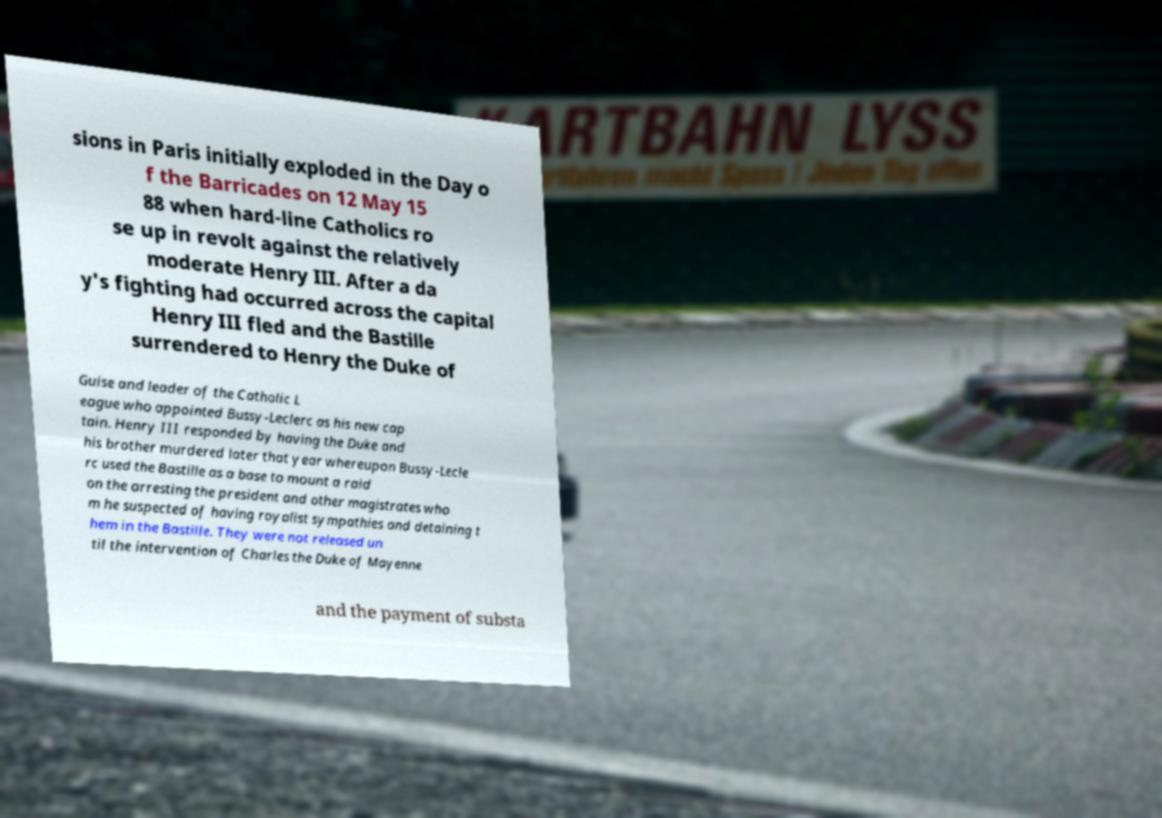For documentation purposes, I need the text within this image transcribed. Could you provide that? sions in Paris initially exploded in the Day o f the Barricades on 12 May 15 88 when hard-line Catholics ro se up in revolt against the relatively moderate Henry III. After a da y's fighting had occurred across the capital Henry III fled and the Bastille surrendered to Henry the Duke of Guise and leader of the Catholic L eague who appointed Bussy-Leclerc as his new cap tain. Henry III responded by having the Duke and his brother murdered later that year whereupon Bussy-Lecle rc used the Bastille as a base to mount a raid on the arresting the president and other magistrates who m he suspected of having royalist sympathies and detaining t hem in the Bastille. They were not released un til the intervention of Charles the Duke of Mayenne and the payment of substa 